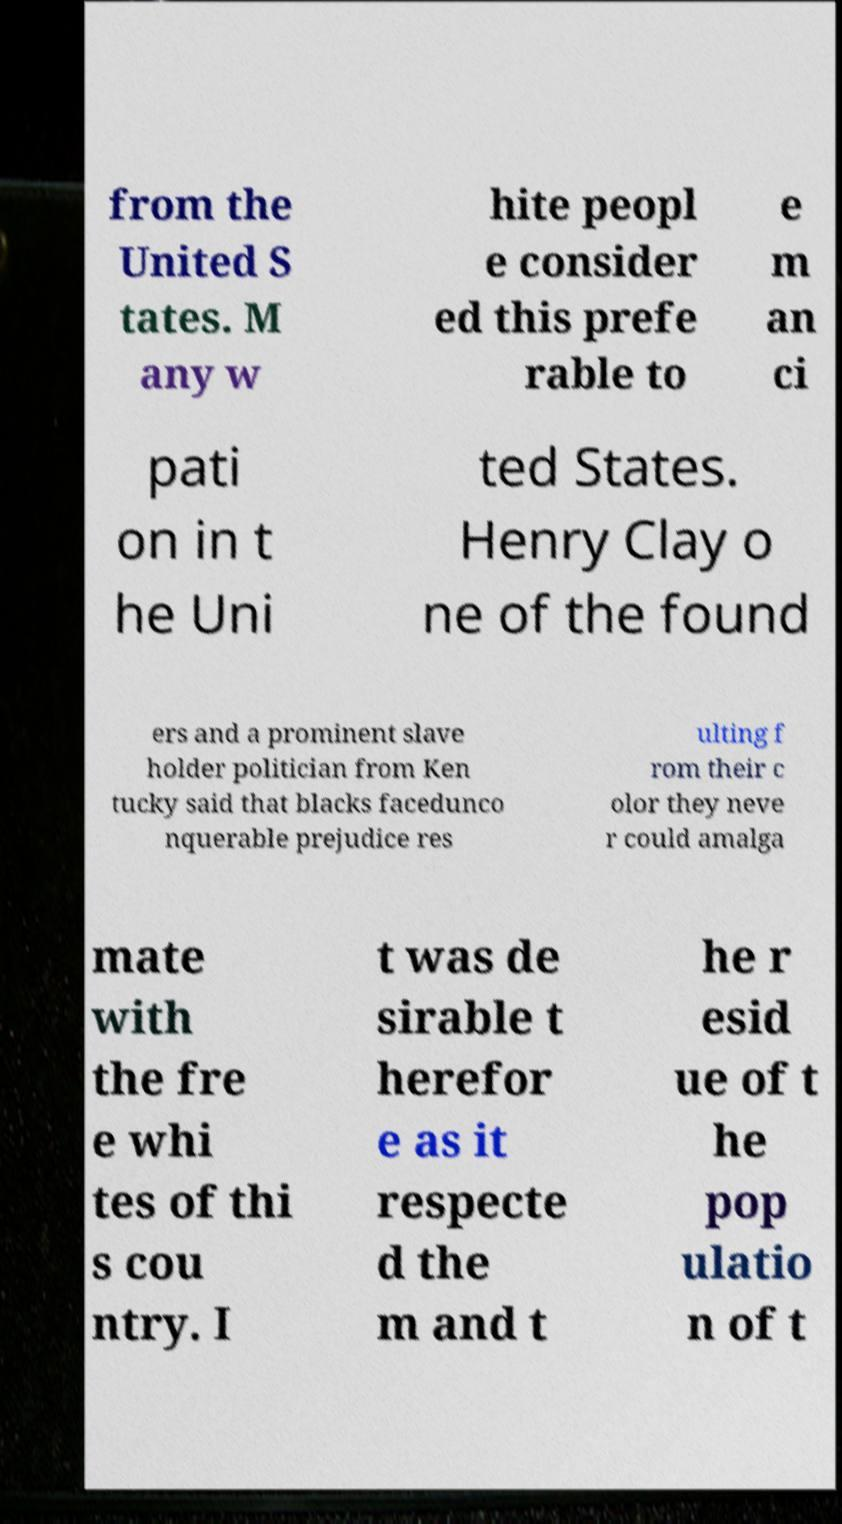What messages or text are displayed in this image? I need them in a readable, typed format. from the United S tates. M any w hite peopl e consider ed this prefe rable to e m an ci pati on in t he Uni ted States. Henry Clay o ne of the found ers and a prominent slave holder politician from Ken tucky said that blacks facedunco nquerable prejudice res ulting f rom their c olor they neve r could amalga mate with the fre e whi tes of thi s cou ntry. I t was de sirable t herefor e as it respecte d the m and t he r esid ue of t he pop ulatio n of t 